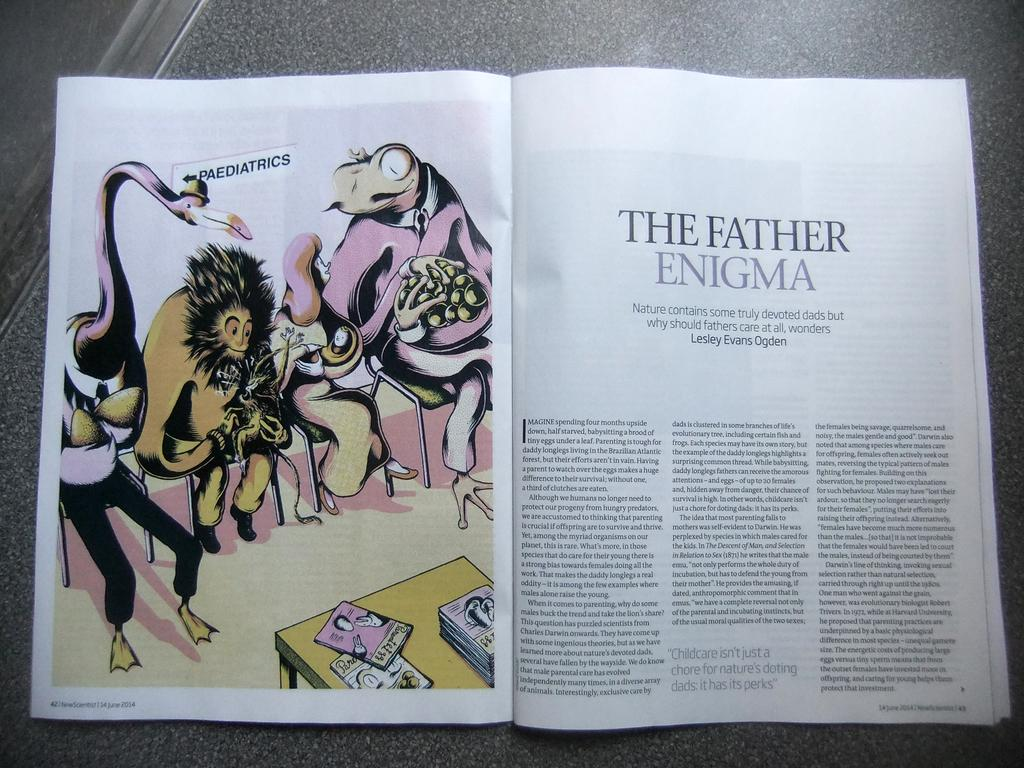<image>
Render a clear and concise summary of the photo. A magazine opened to an article entitled The Father Enigma with an illustration on the left side of the page. 